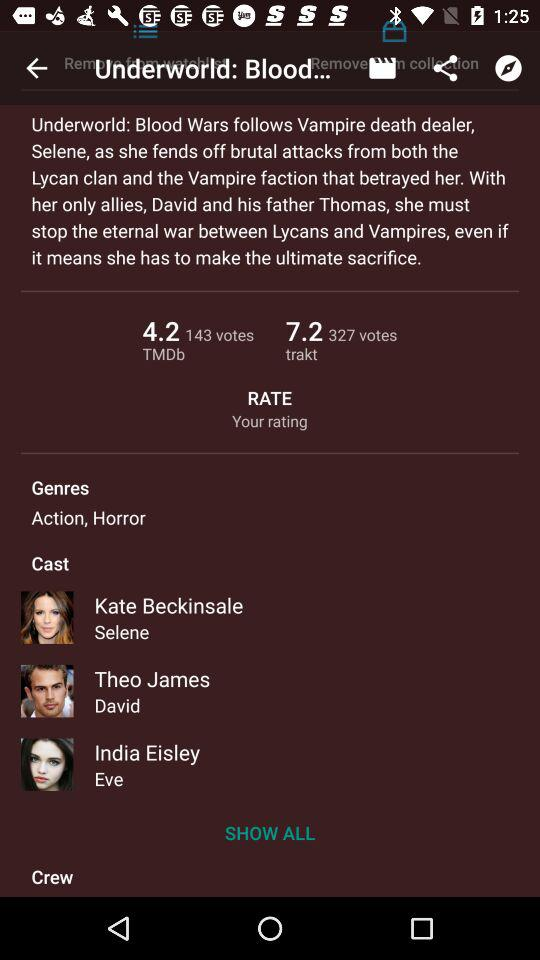What is the trakt of the movie? The trakt of the movie is 7.2. 